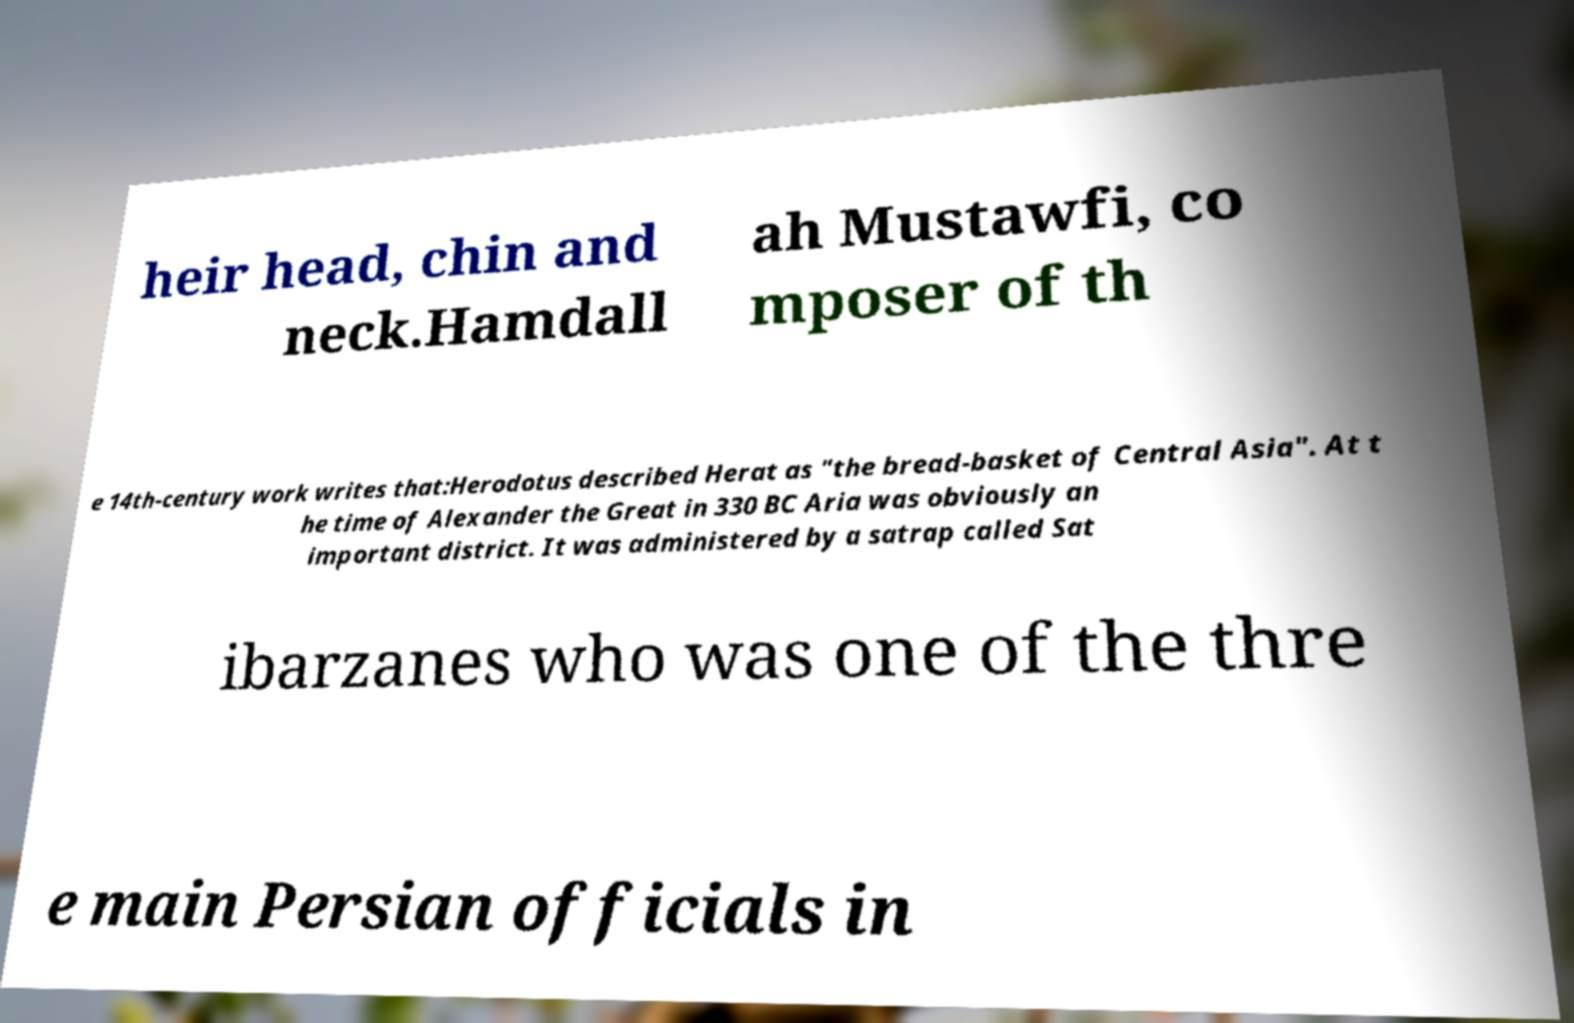For documentation purposes, I need the text within this image transcribed. Could you provide that? heir head, chin and neck.Hamdall ah Mustawfi, co mposer of th e 14th-century work writes that:Herodotus described Herat as "the bread-basket of Central Asia". At t he time of Alexander the Great in 330 BC Aria was obviously an important district. It was administered by a satrap called Sat ibarzanes who was one of the thre e main Persian officials in 